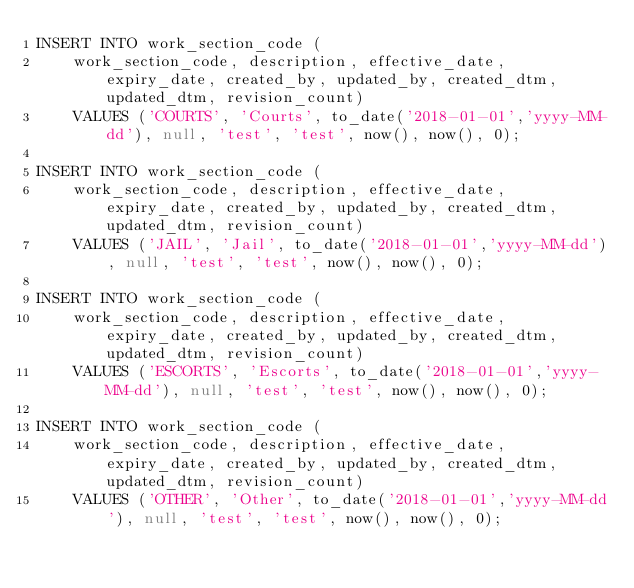Convert code to text. <code><loc_0><loc_0><loc_500><loc_500><_SQL_>INSERT INTO work_section_code (
	work_section_code, description, effective_date, expiry_date, created_by, updated_by, created_dtm, updated_dtm, revision_count)
	VALUES ('COURTS', 'Courts', to_date('2018-01-01','yyyy-MM-dd'), null, 'test', 'test', now(), now(), 0);

INSERT INTO work_section_code (
	work_section_code, description, effective_date, expiry_date, created_by, updated_by, created_dtm, updated_dtm, revision_count)
	VALUES ('JAIL', 'Jail', to_date('2018-01-01','yyyy-MM-dd'), null, 'test', 'test', now(), now(), 0);

INSERT INTO work_section_code (
	work_section_code, description, effective_date, expiry_date, created_by, updated_by, created_dtm, updated_dtm, revision_count)
	VALUES ('ESCORTS', 'Escorts', to_date('2018-01-01','yyyy-MM-dd'), null, 'test', 'test', now(), now(), 0);

INSERT INTO work_section_code (
	work_section_code, description, effective_date, expiry_date, created_by, updated_by, created_dtm, updated_dtm, revision_count)
	VALUES ('OTHER', 'Other', to_date('2018-01-01','yyyy-MM-dd'), null, 'test', 'test', now(), now(), 0);
</code> 